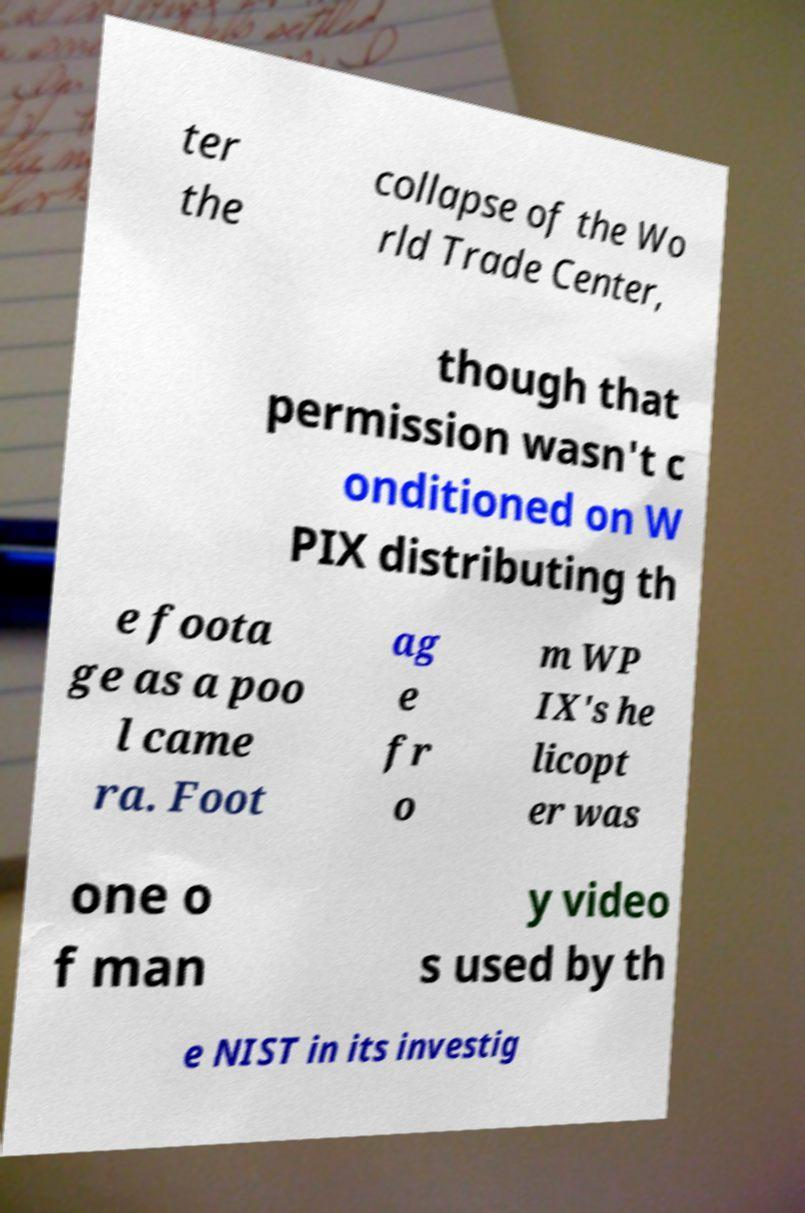For documentation purposes, I need the text within this image transcribed. Could you provide that? ter the collapse of the Wo rld Trade Center, though that permission wasn't c onditioned on W PIX distributing th e foota ge as a poo l came ra. Foot ag e fr o m WP IX's he licopt er was one o f man y video s used by th e NIST in its investig 